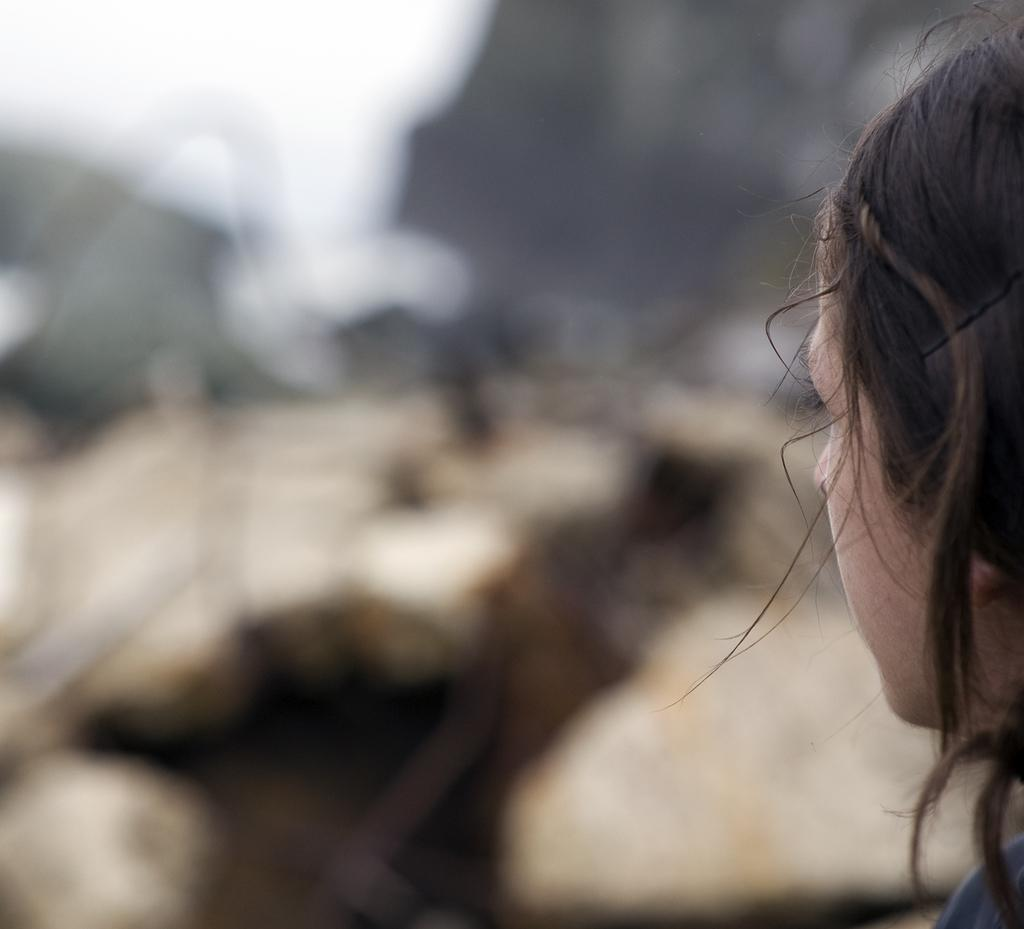What is the main subject of the image? There is a person in the image. Can you describe the background of the image? The background of the image is blurred. How many spoons are visible in the image? There is no spoon present in the image. What type of horses can be seen in the image? There are no horses present in the image. 